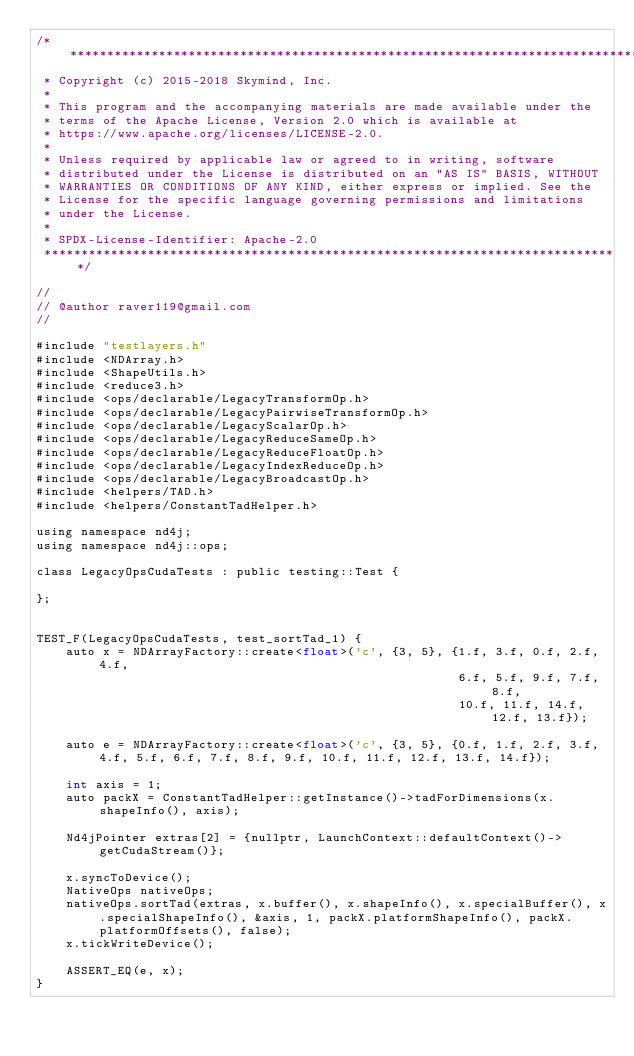Convert code to text. <code><loc_0><loc_0><loc_500><loc_500><_Cuda_>/*******************************************************************************
 * Copyright (c) 2015-2018 Skymind, Inc.
 *
 * This program and the accompanying materials are made available under the
 * terms of the Apache License, Version 2.0 which is available at
 * https://www.apache.org/licenses/LICENSE-2.0.
 *
 * Unless required by applicable law or agreed to in writing, software
 * distributed under the License is distributed on an "AS IS" BASIS, WITHOUT
 * WARRANTIES OR CONDITIONS OF ANY KIND, either express or implied. See the
 * License for the specific language governing permissions and limitations
 * under the License.
 *
 * SPDX-License-Identifier: Apache-2.0
 ******************************************************************************/

//
// @author raver119@gmail.com
//

#include "testlayers.h"
#include <NDArray.h>
#include <ShapeUtils.h>
#include <reduce3.h>
#include <ops/declarable/LegacyTransformOp.h>
#include <ops/declarable/LegacyPairwiseTransformOp.h>
#include <ops/declarable/LegacyScalarOp.h>
#include <ops/declarable/LegacyReduceSameOp.h>
#include <ops/declarable/LegacyReduceFloatOp.h>
#include <ops/declarable/LegacyIndexReduceOp.h>
#include <ops/declarable/LegacyBroadcastOp.h>
#include <helpers/TAD.h>
#include <helpers/ConstantTadHelper.h>

using namespace nd4j;
using namespace nd4j::ops;

class LegacyOpsCudaTests : public testing::Test {

};


TEST_F(LegacyOpsCudaTests, test_sortTad_1) {
    auto x = NDArrayFactory::create<float>('c', {3, 5}, {1.f, 3.f, 0.f, 2.f, 4.f,
                                                         6.f, 5.f, 9.f, 7.f, 8.f,
                                                         10.f, 11.f, 14.f, 12.f, 13.f});

    auto e = NDArrayFactory::create<float>('c', {3, 5}, {0.f, 1.f, 2.f, 3.f, 4.f, 5.f, 6.f, 7.f, 8.f, 9.f, 10.f, 11.f, 12.f, 13.f, 14.f});

    int axis = 1;
    auto packX = ConstantTadHelper::getInstance()->tadForDimensions(x.shapeInfo(), axis);

    Nd4jPointer extras[2] = {nullptr, LaunchContext::defaultContext()->getCudaStream()};

    x.syncToDevice();
    NativeOps nativeOps;
    nativeOps.sortTad(extras, x.buffer(), x.shapeInfo(), x.specialBuffer(), x.specialShapeInfo(), &axis, 1, packX.platformShapeInfo(), packX.platformOffsets(), false);
    x.tickWriteDevice();

    ASSERT_EQ(e, x);
}</code> 